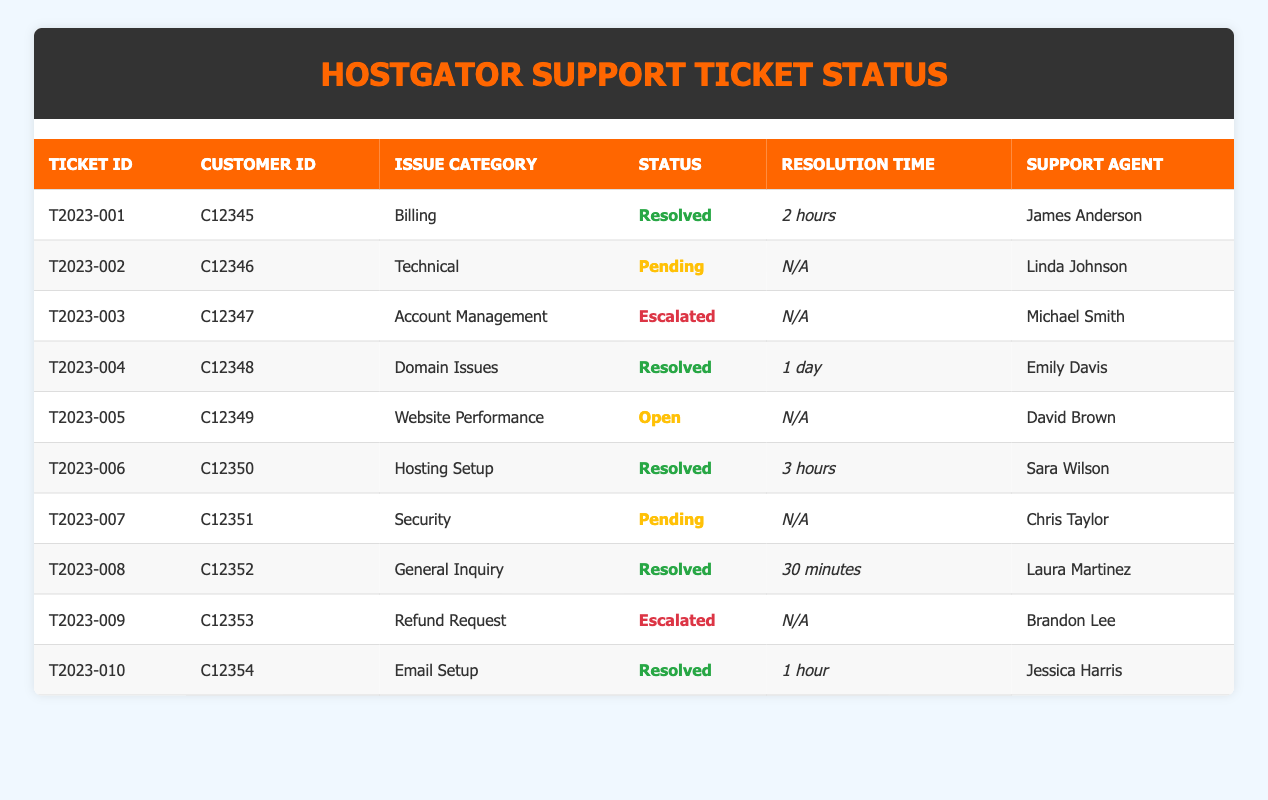What are the statuses of the support tickets? The statuses can be found in the "Status" column of the table. They include "Resolved," "Pending," "Escalated," and "Open." By observing each row, we can see that there are various statuses assigned to each ticket.
Answer: Resolved, Pending, Escalated, Open How many tickets were resolved in total? To determine this, I will count the rows in the table where the "Status" is "Resolved." Referring to the table, there are 5 tickets with the status "Resolved."
Answer: 5 Which support agent took the most tickets? I will count how many tickets each support agent has handled by checking the "Support Agent" column. After reviewing the table, all agents have handled just one ticket each, except for one agent, James Anderson, who handled one. Hence, no agent took more than one ticket.
Answer: No agent took more than one ticket Is there a ticket that has a status of "Escalated"? I will look at the "Status" column in the table to see if "Escalated" appears. Scanning through the rows, I find two tickets with the status "Escalated."
Answer: Yes What is the average resolution time for resolved tickets? First, I will list the resolution times of all resolved tickets: 2 hours, 1 day (24 hours), 3 hours, 30 minutes (0.5 hours), and 1 hour. I need to convert all times to hours: 2, 24, 3, 0.5, 1. Summing these gives 30.5 hours. There are 5 resolved tickets, so dividing 30.5 by 5 gives the average time.
Answer: 6.1 hours 